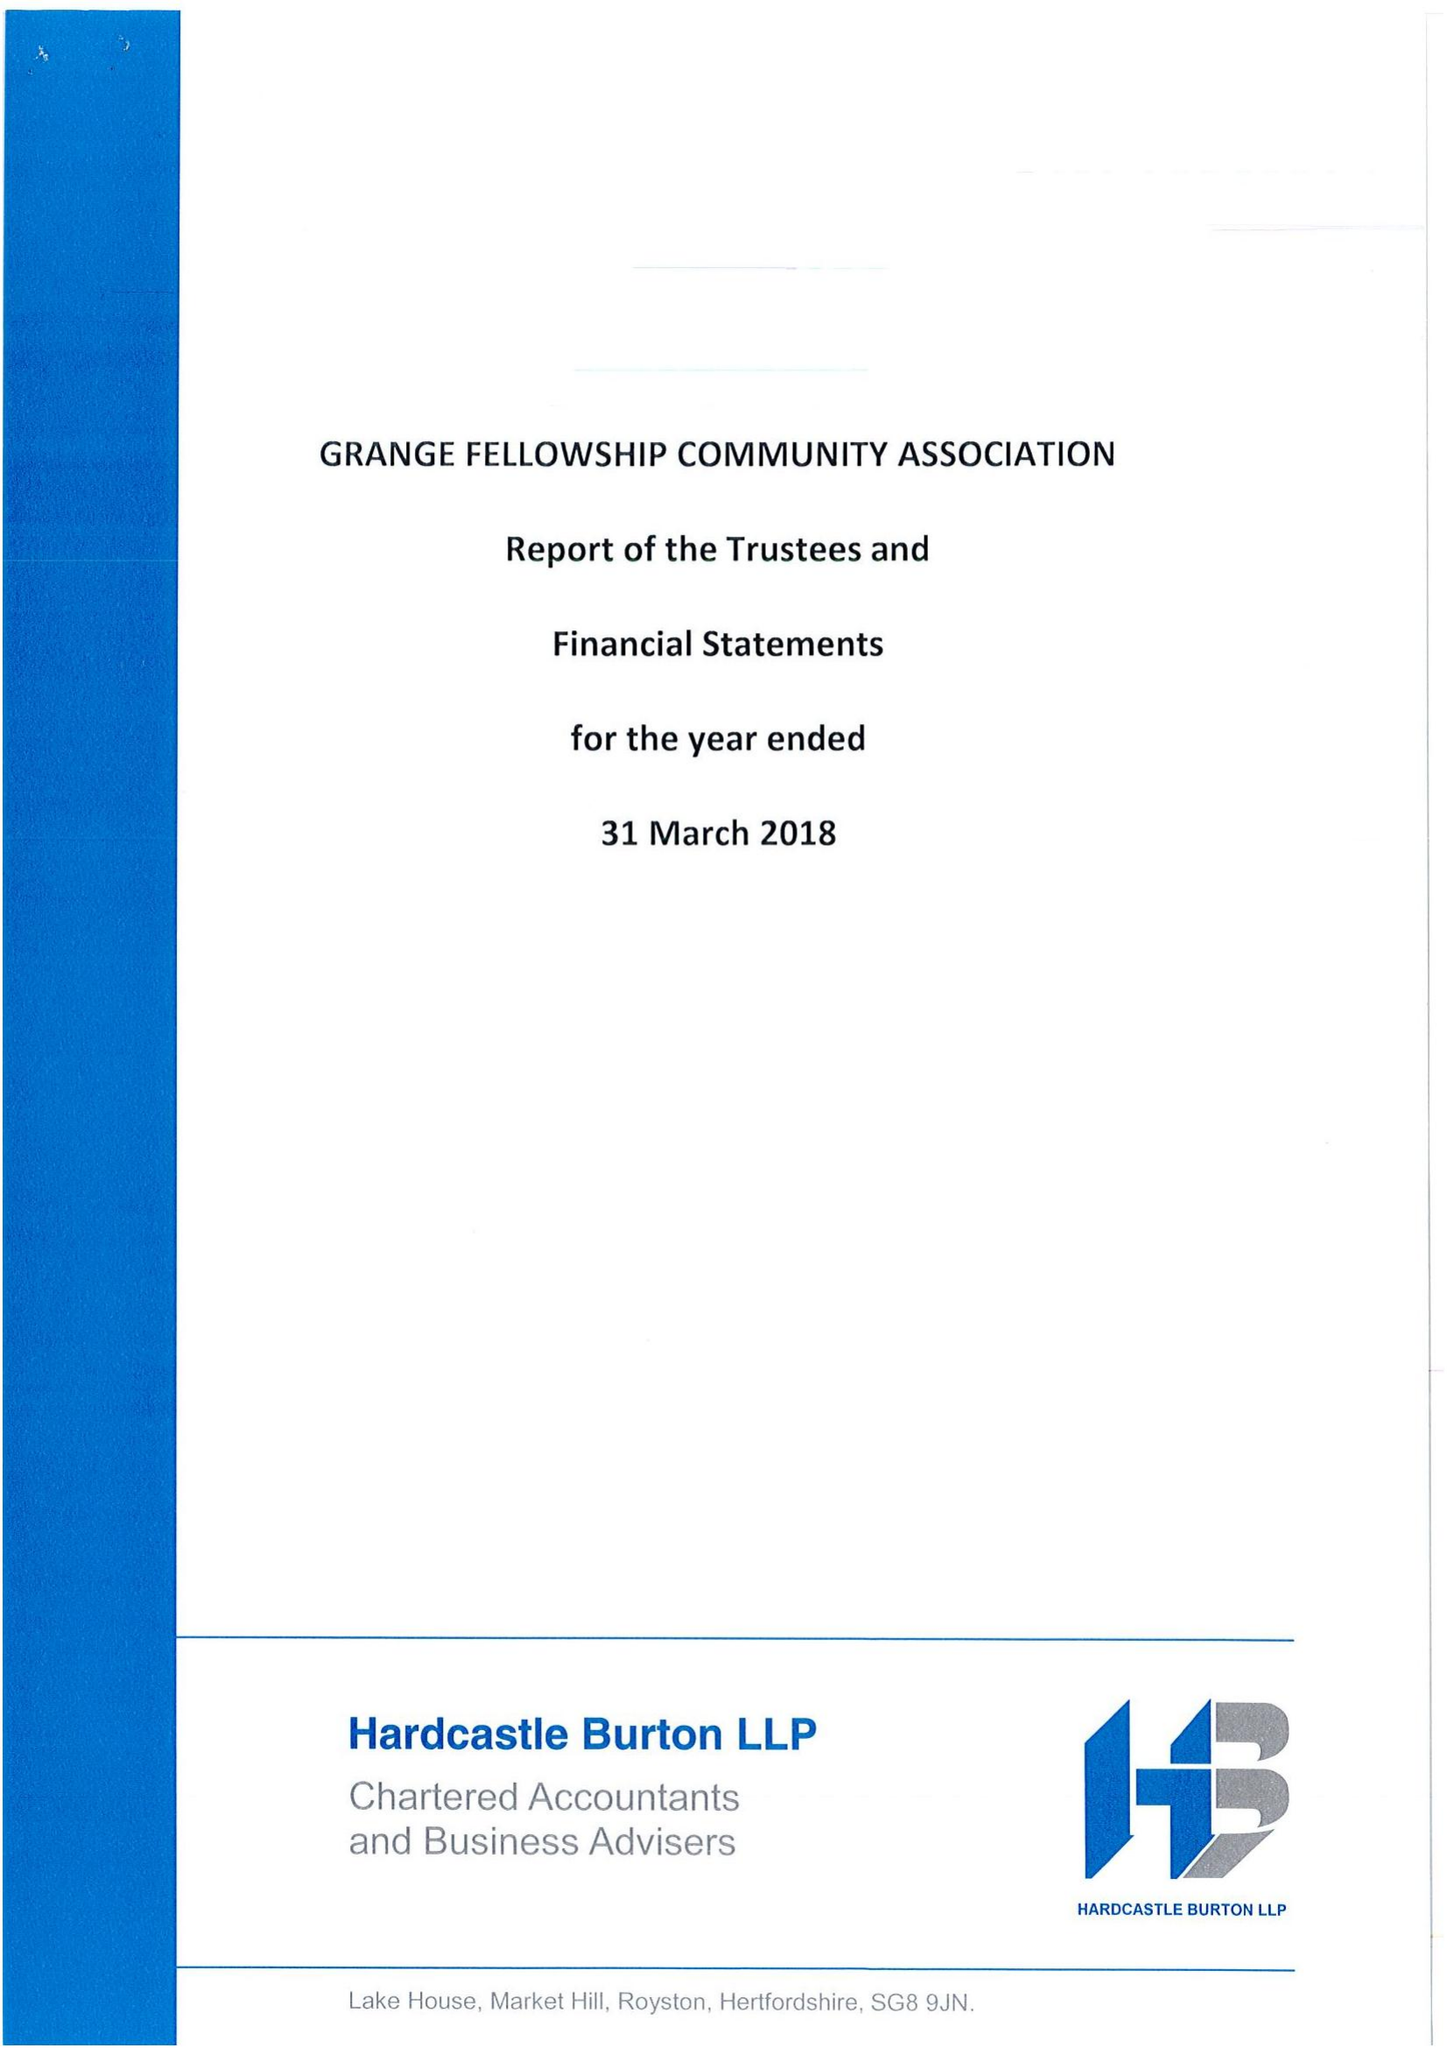What is the value for the address__post_town?
Answer the question using a single word or phrase. LETCHWORTH GARDEN CITY 